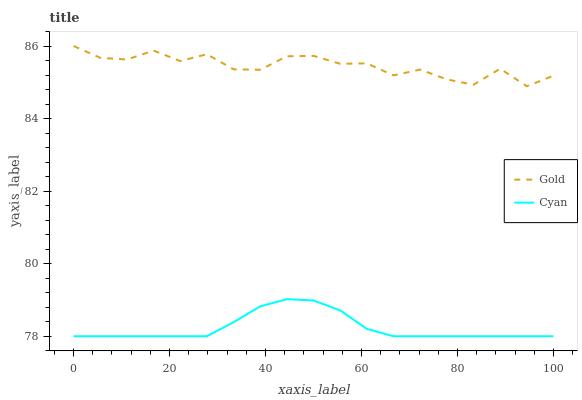Does Cyan have the minimum area under the curve?
Answer yes or no. Yes. Does Gold have the maximum area under the curve?
Answer yes or no. Yes. Does Gold have the minimum area under the curve?
Answer yes or no. No. Is Cyan the smoothest?
Answer yes or no. Yes. Is Gold the roughest?
Answer yes or no. Yes. Is Gold the smoothest?
Answer yes or no. No. Does Cyan have the lowest value?
Answer yes or no. Yes. Does Gold have the lowest value?
Answer yes or no. No. Does Gold have the highest value?
Answer yes or no. Yes. Is Cyan less than Gold?
Answer yes or no. Yes. Is Gold greater than Cyan?
Answer yes or no. Yes. Does Cyan intersect Gold?
Answer yes or no. No. 